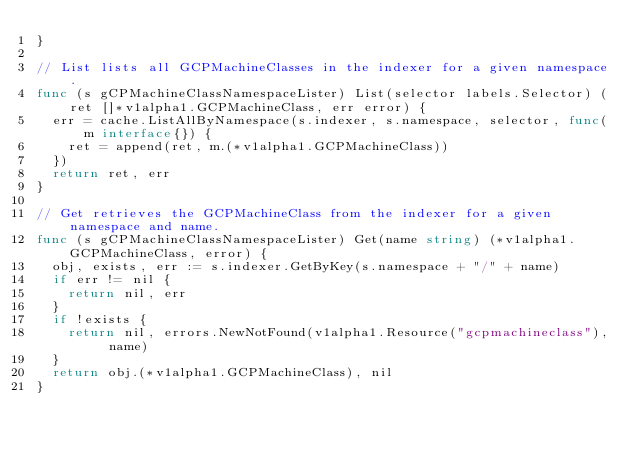<code> <loc_0><loc_0><loc_500><loc_500><_Go_>}

// List lists all GCPMachineClasses in the indexer for a given namespace.
func (s gCPMachineClassNamespaceLister) List(selector labels.Selector) (ret []*v1alpha1.GCPMachineClass, err error) {
	err = cache.ListAllByNamespace(s.indexer, s.namespace, selector, func(m interface{}) {
		ret = append(ret, m.(*v1alpha1.GCPMachineClass))
	})
	return ret, err
}

// Get retrieves the GCPMachineClass from the indexer for a given namespace and name.
func (s gCPMachineClassNamespaceLister) Get(name string) (*v1alpha1.GCPMachineClass, error) {
	obj, exists, err := s.indexer.GetByKey(s.namespace + "/" + name)
	if err != nil {
		return nil, err
	}
	if !exists {
		return nil, errors.NewNotFound(v1alpha1.Resource("gcpmachineclass"), name)
	}
	return obj.(*v1alpha1.GCPMachineClass), nil
}
</code> 